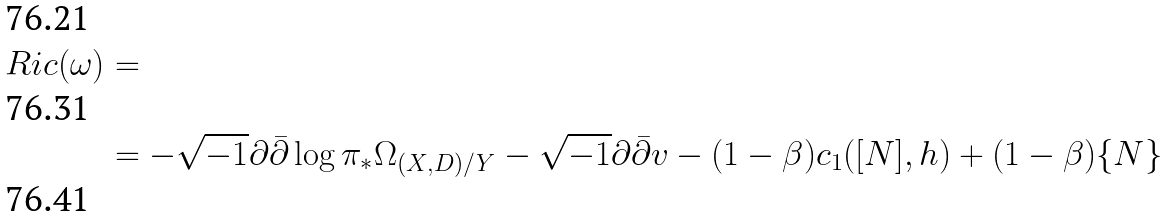Convert formula to latex. <formula><loc_0><loc_0><loc_500><loc_500>R i c ( \omega ) & = \\ & = - \sqrt { - 1 } \partial \bar { \partial } \log \pi _ { * } \Omega _ { ( X , D ) / Y } - \sqrt { - 1 } \partial \bar { \partial } v - ( 1 - \beta ) c _ { 1 } ( [ N ] , h ) + ( 1 - \beta ) \{ N \} \\</formula> 